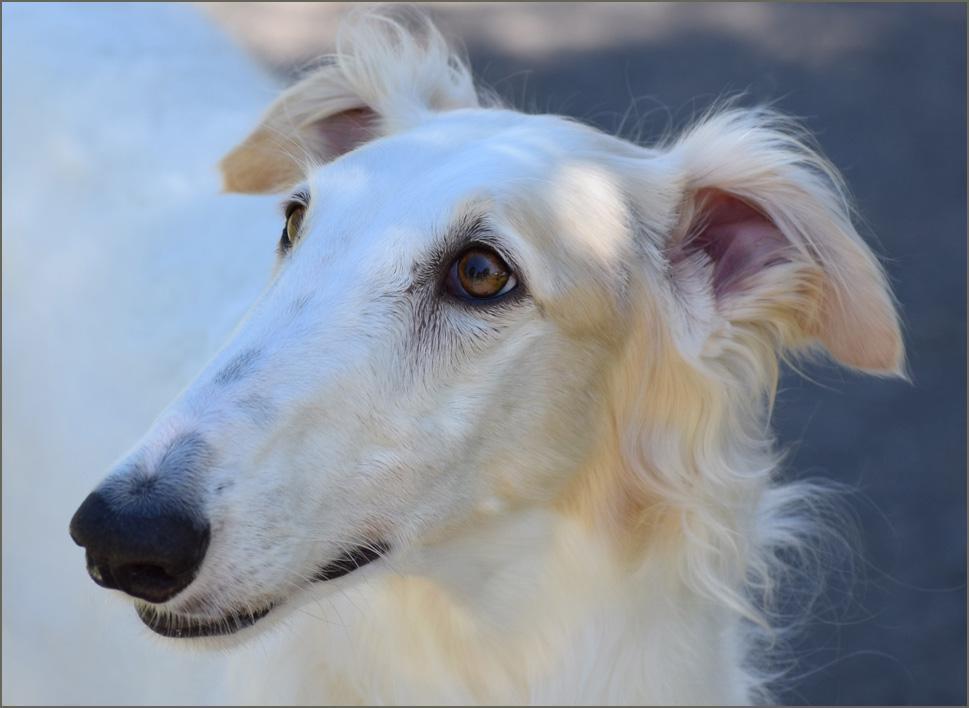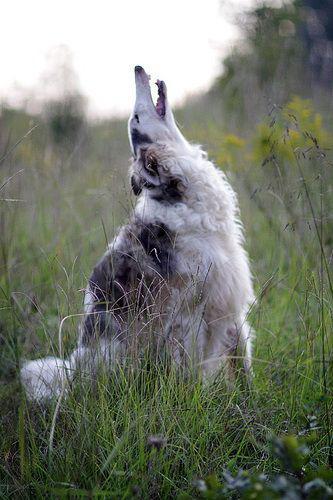The first image is the image on the left, the second image is the image on the right. Assess this claim about the two images: "The right image contains two dogs.". Correct or not? Answer yes or no. No. The first image is the image on the left, the second image is the image on the right. Given the left and right images, does the statement "At least one of the dogs has its mouth open" hold true? Answer yes or no. Yes. 